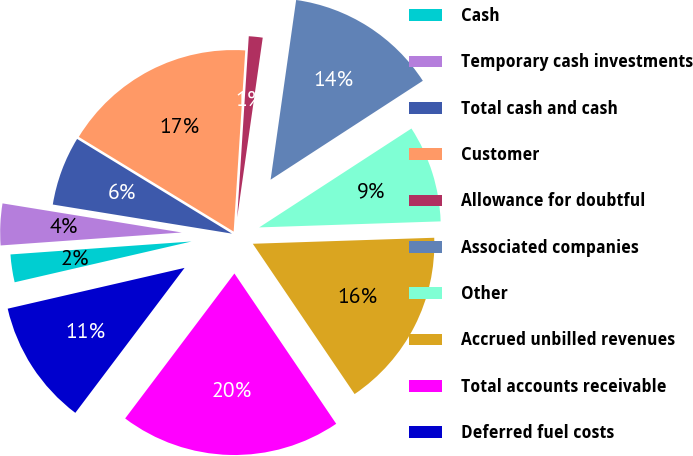Convert chart to OTSL. <chart><loc_0><loc_0><loc_500><loc_500><pie_chart><fcel>Cash<fcel>Temporary cash investments<fcel>Total cash and cash<fcel>Customer<fcel>Allowance for doubtful<fcel>Associated companies<fcel>Other<fcel>Accrued unbilled revenues<fcel>Total accounts receivable<fcel>Deferred fuel costs<nl><fcel>2.47%<fcel>3.7%<fcel>6.17%<fcel>17.28%<fcel>1.23%<fcel>13.58%<fcel>8.64%<fcel>16.05%<fcel>19.75%<fcel>11.11%<nl></chart> 